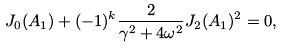<formula> <loc_0><loc_0><loc_500><loc_500>J _ { 0 } ( A _ { 1 } ) + ( - 1 ) ^ { k } \frac { 2 } { \gamma ^ { 2 } + 4 \omega ^ { 2 } } J _ { 2 } ( A _ { 1 } ) ^ { 2 } = 0 ,</formula> 